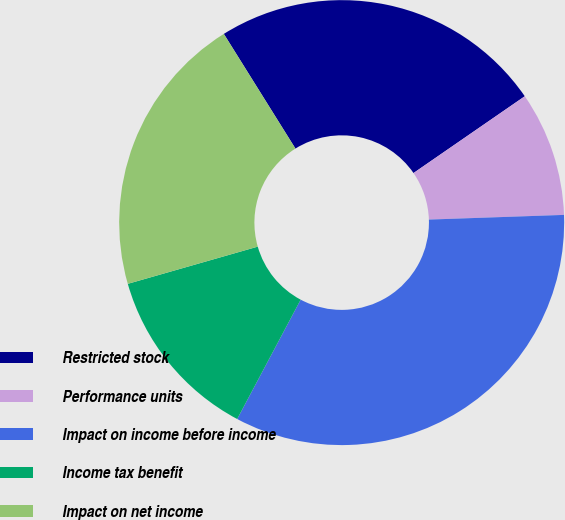Convert chart to OTSL. <chart><loc_0><loc_0><loc_500><loc_500><pie_chart><fcel>Restricted stock<fcel>Performance units<fcel>Impact on income before income<fcel>Income tax benefit<fcel>Impact on net income<nl><fcel>24.27%<fcel>9.06%<fcel>33.33%<fcel>12.78%<fcel>20.55%<nl></chart> 